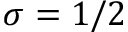<formula> <loc_0><loc_0><loc_500><loc_500>\sigma = 1 / 2</formula> 